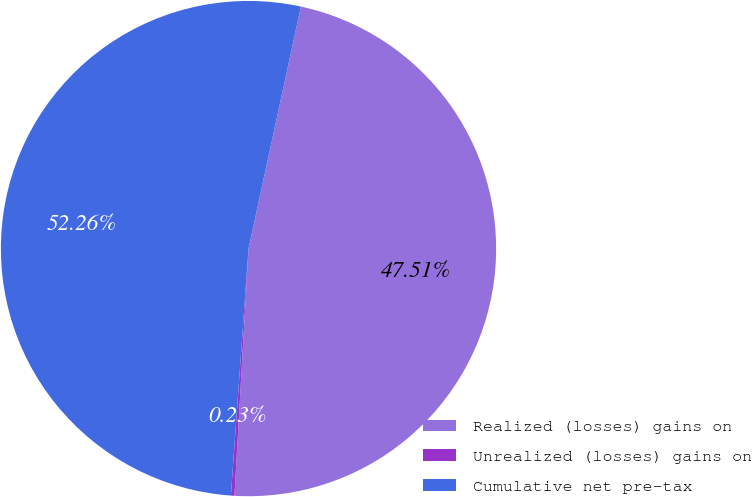<chart> <loc_0><loc_0><loc_500><loc_500><pie_chart><fcel>Realized (losses) gains on<fcel>Unrealized (losses) gains on<fcel>Cumulative net pre-tax<nl><fcel>47.51%<fcel>0.23%<fcel>52.26%<nl></chart> 